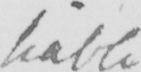Can you tell me what this handwritten text says? liable 